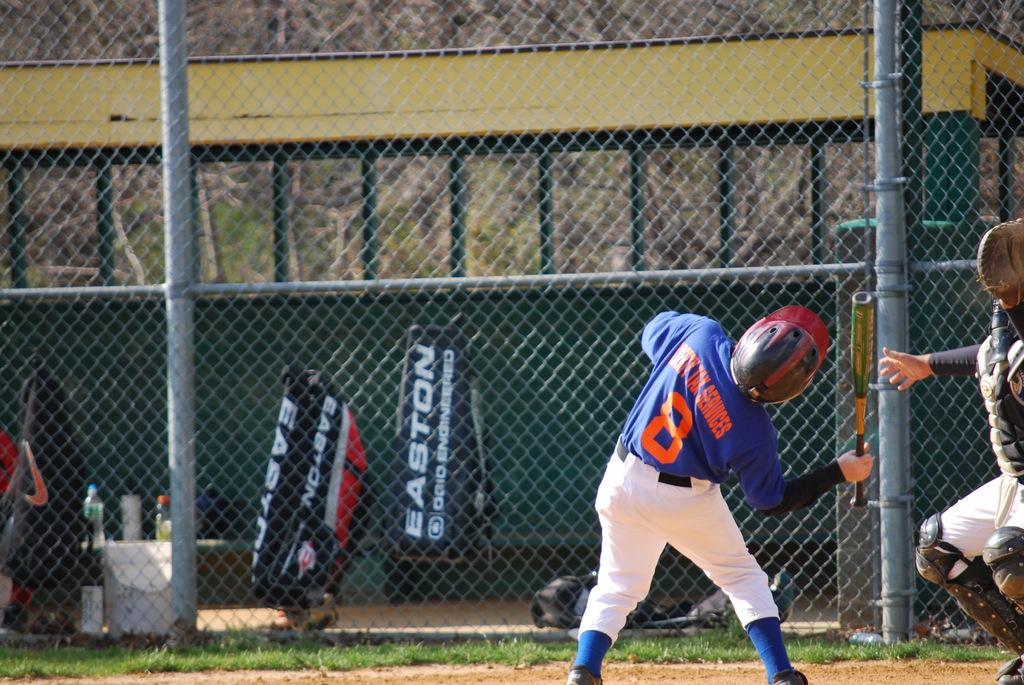<image>
Offer a succinct explanation of the picture presented. A batter whose number is 8 is ducking in the batter's box from a high pitch.. 